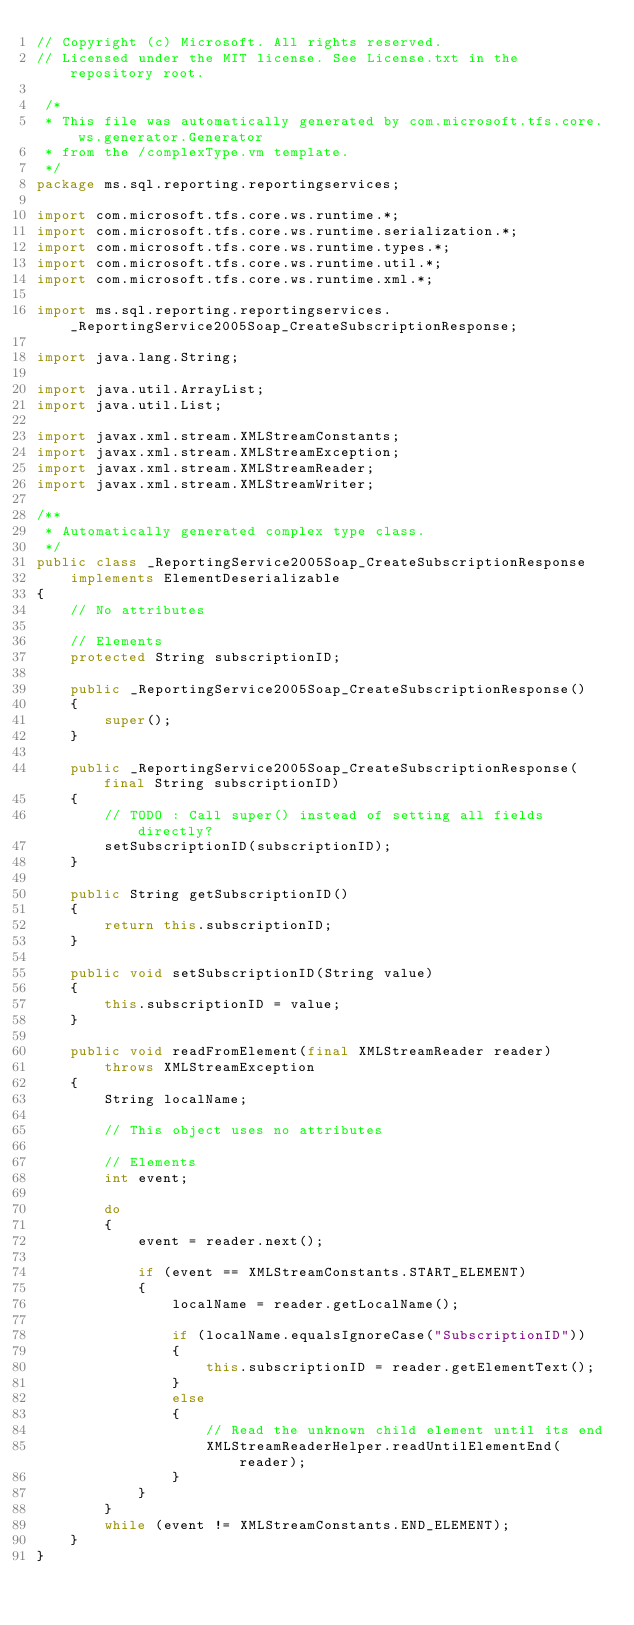Convert code to text. <code><loc_0><loc_0><loc_500><loc_500><_Java_>// Copyright (c) Microsoft. All rights reserved.
// Licensed under the MIT license. See License.txt in the repository root.

 /*
 * This file was automatically generated by com.microsoft.tfs.core.ws.generator.Generator
 * from the /complexType.vm template.
 */
package ms.sql.reporting.reportingservices;

import com.microsoft.tfs.core.ws.runtime.*;
import com.microsoft.tfs.core.ws.runtime.serialization.*;
import com.microsoft.tfs.core.ws.runtime.types.*;
import com.microsoft.tfs.core.ws.runtime.util.*;
import com.microsoft.tfs.core.ws.runtime.xml.*;

import ms.sql.reporting.reportingservices._ReportingService2005Soap_CreateSubscriptionResponse;

import java.lang.String;

import java.util.ArrayList;
import java.util.List;

import javax.xml.stream.XMLStreamConstants;
import javax.xml.stream.XMLStreamException;
import javax.xml.stream.XMLStreamReader;
import javax.xml.stream.XMLStreamWriter;

/**
 * Automatically generated complex type class.
 */
public class _ReportingService2005Soap_CreateSubscriptionResponse
    implements ElementDeserializable
{
    // No attributes    

    // Elements
    protected String subscriptionID;

    public _ReportingService2005Soap_CreateSubscriptionResponse()
    {
        super();
    }

    public _ReportingService2005Soap_CreateSubscriptionResponse(final String subscriptionID)
    {
        // TODO : Call super() instead of setting all fields directly?
        setSubscriptionID(subscriptionID);
    }

    public String getSubscriptionID()
    {
        return this.subscriptionID;
    }

    public void setSubscriptionID(String value)
    {
        this.subscriptionID = value;
    }

    public void readFromElement(final XMLStreamReader reader)
        throws XMLStreamException
    {
        String localName;

        // This object uses no attributes

        // Elements
        int event;

        do
        {
            event = reader.next();

            if (event == XMLStreamConstants.START_ELEMENT)
            {
                localName = reader.getLocalName();

                if (localName.equalsIgnoreCase("SubscriptionID"))
                {
                    this.subscriptionID = reader.getElementText();
                }
                else
                {
                    // Read the unknown child element until its end
                    XMLStreamReaderHelper.readUntilElementEnd(reader);
                }
            }
        }
        while (event != XMLStreamConstants.END_ELEMENT);
    }
}
</code> 